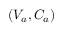<formula> <loc_0><loc_0><loc_500><loc_500>\left ( V _ { a } , C _ { a } \right )</formula> 